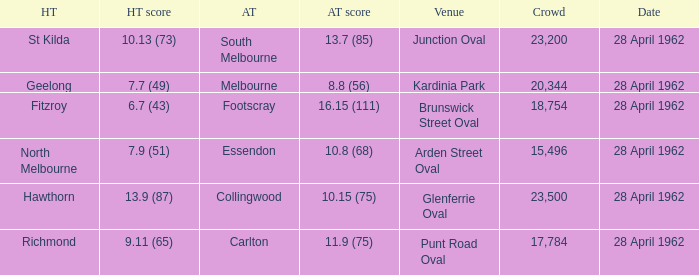13 (73)? 23200.0. 